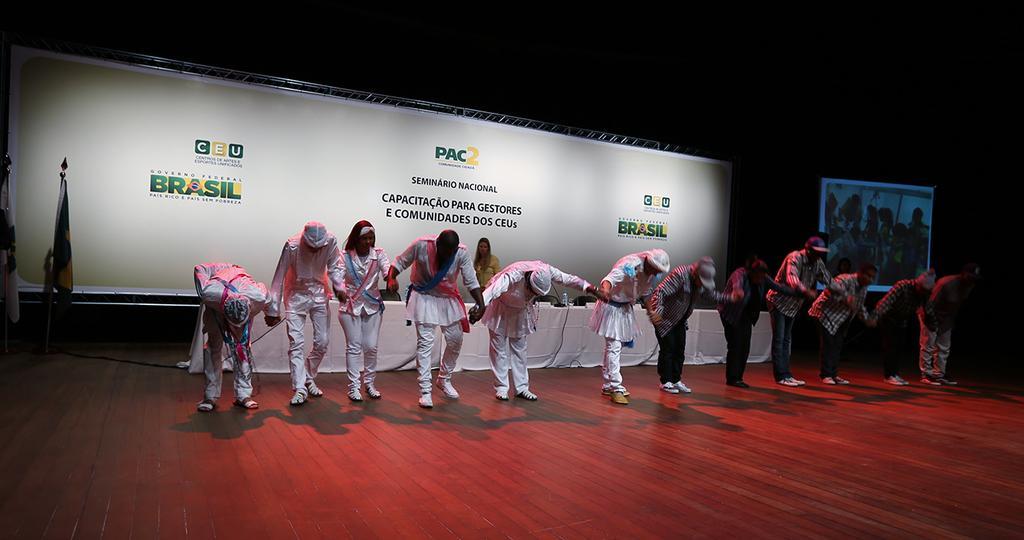Please provide a concise description of this image. In this image in front there are people standing on the floor. Behind them there is a table and on top of the it there are few objects. On the left side of the image there are flags. In the background of the image there is a banner. There is a screen. 